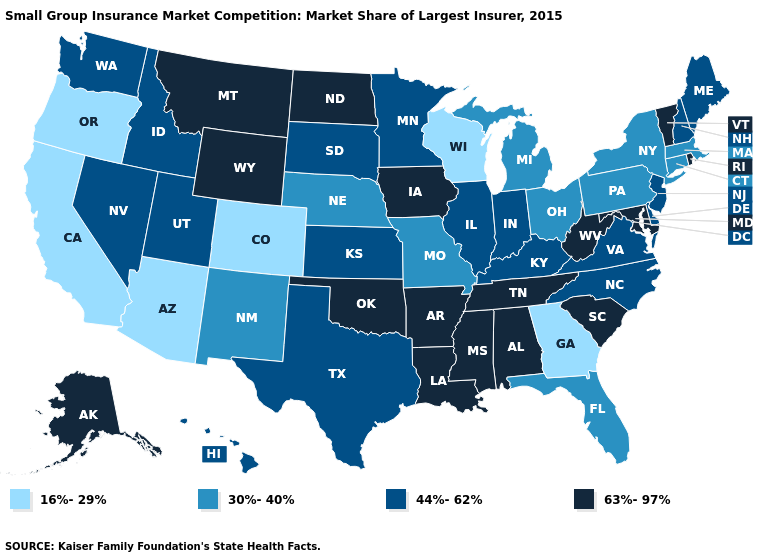What is the highest value in states that border West Virginia?
Quick response, please. 63%-97%. Name the states that have a value in the range 44%-62%?
Write a very short answer. Delaware, Hawaii, Idaho, Illinois, Indiana, Kansas, Kentucky, Maine, Minnesota, Nevada, New Hampshire, New Jersey, North Carolina, South Dakota, Texas, Utah, Virginia, Washington. How many symbols are there in the legend?
Keep it brief. 4. Does the first symbol in the legend represent the smallest category?
Quick response, please. Yes. Name the states that have a value in the range 63%-97%?
Concise answer only. Alabama, Alaska, Arkansas, Iowa, Louisiana, Maryland, Mississippi, Montana, North Dakota, Oklahoma, Rhode Island, South Carolina, Tennessee, Vermont, West Virginia, Wyoming. Is the legend a continuous bar?
Keep it brief. No. What is the value of Alabama?
Answer briefly. 63%-97%. What is the value of New Jersey?
Keep it brief. 44%-62%. What is the highest value in states that border California?
Quick response, please. 44%-62%. What is the value of Arizona?
Concise answer only. 16%-29%. Among the states that border Utah , which have the highest value?
Quick response, please. Wyoming. Among the states that border Florida , which have the highest value?
Short answer required. Alabama. Does Wisconsin have the highest value in the MidWest?
Short answer required. No. Among the states that border Alabama , which have the highest value?
Answer briefly. Mississippi, Tennessee. Name the states that have a value in the range 16%-29%?
Write a very short answer. Arizona, California, Colorado, Georgia, Oregon, Wisconsin. 